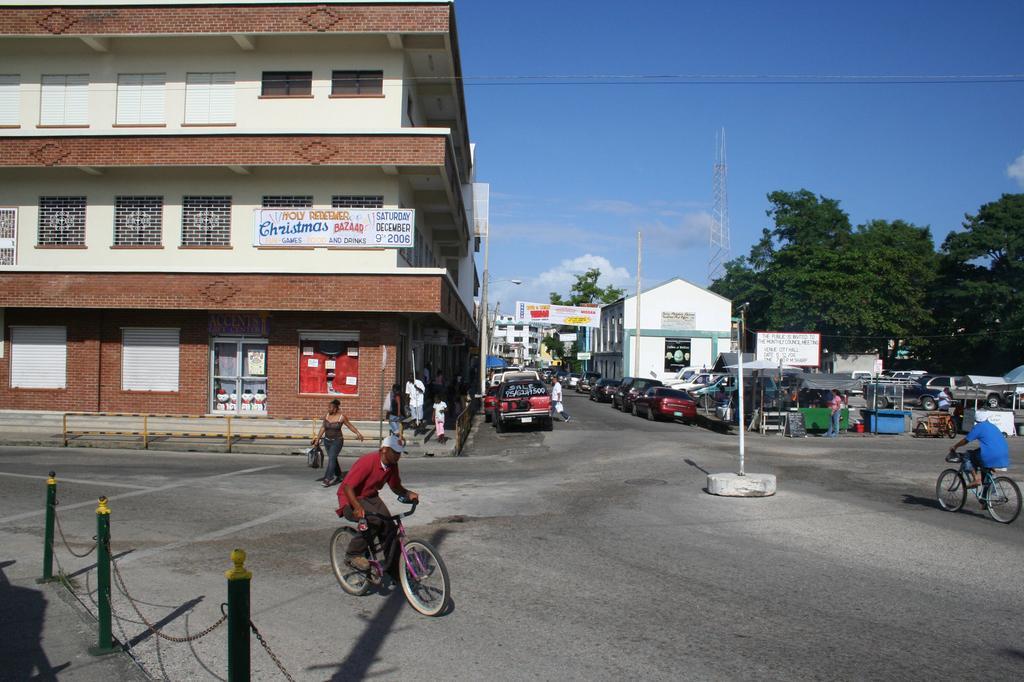Can you describe this image briefly? In the foreground of this image, there is railing on the left and also we can see two men cycling on the road and few are walking on it. In the middle, there is a pole. In the background, there are buildings, vehicles, boards, poles, trees and the sky. 